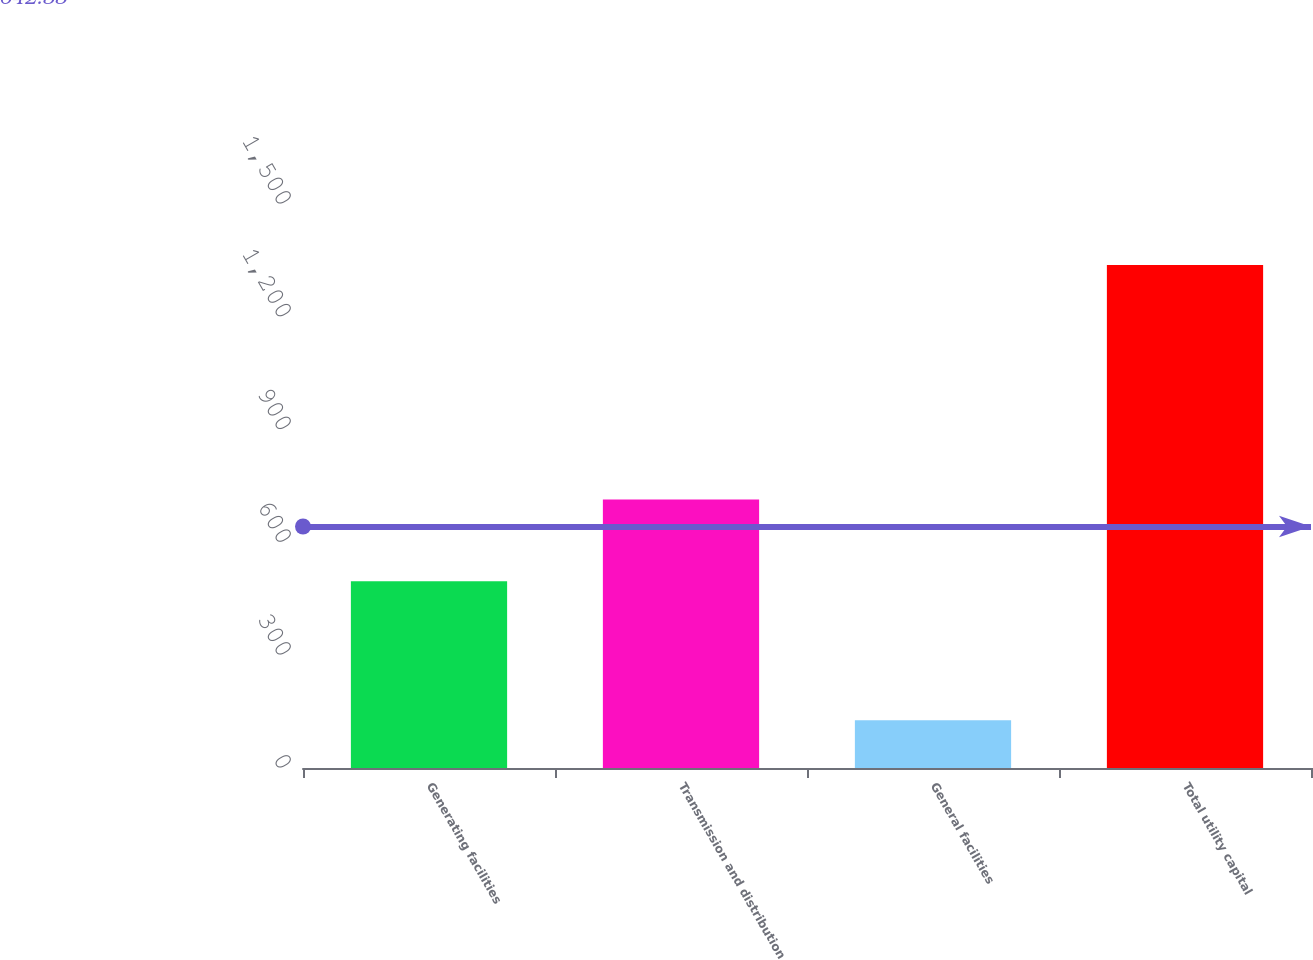Convert chart. <chart><loc_0><loc_0><loc_500><loc_500><bar_chart><fcel>Generating facilities<fcel>Transmission and distribution<fcel>General facilities<fcel>Total utility capital<nl><fcel>497<fcel>714<fcel>127<fcel>1338<nl></chart> 